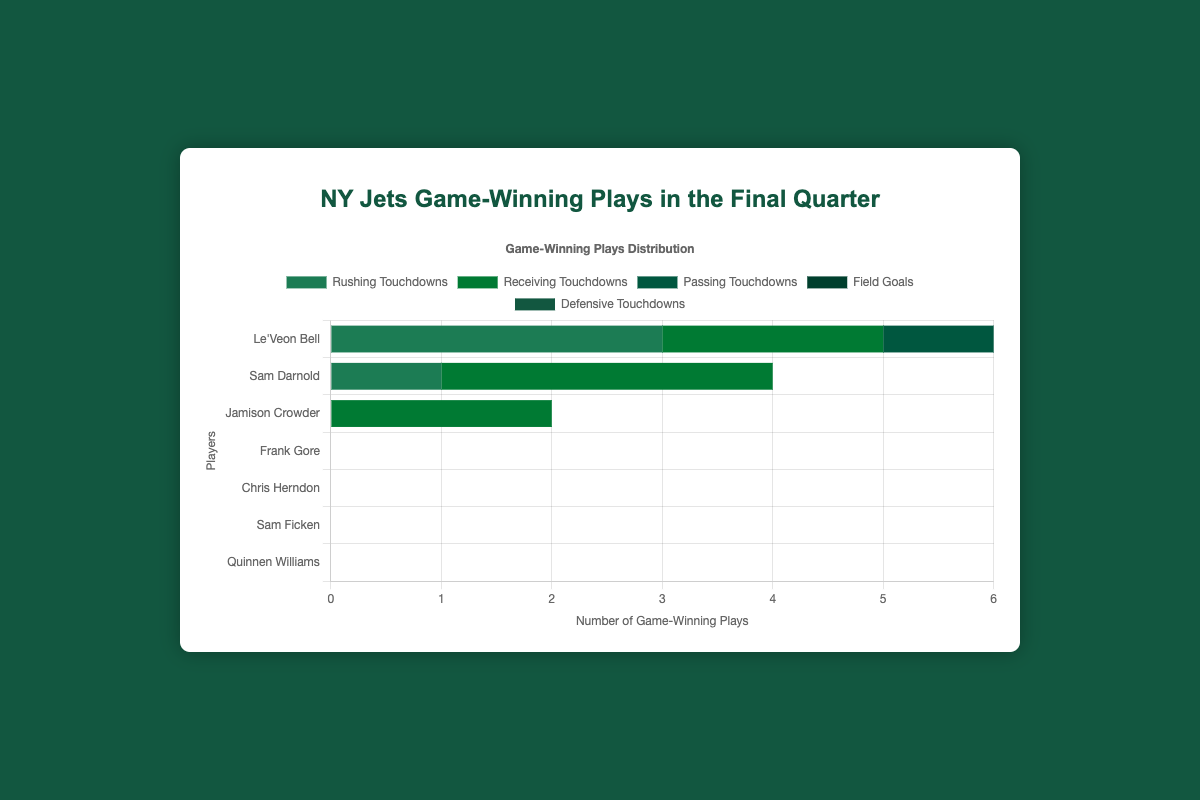Who has the most game-winning plays in the final quarter? By looking at the chart, observe the tallest bar. The "Field Goals" bar for Sam Ficken is the tallest with a height corresponding to 5 game-winning plays. So, Sam Ficken has the most game-winning plays.
Answer: Sam Ficken How many rushing touchdowns does Le'Veon Bell have compared to Frank Gore? Refer to the bars labeled "Rushing Touchdowns" for both players. Le'Veon Bell has 3 game-winning rushing touchdowns, while Frank Gore has 1.
Answer: 3 vs 1 What is the total number of game-winning plays made by Le'Veon Bell? Observe the bars corresponding to Le'Veon Bell and sum their values. Le'Veon Bell has 3 rushing touchdowns and 2 receiving touchdowns, adding up to a total of 5 game-winning plays.
Answer: 5 Which type of play has the highest number of game-winning plays? Look at the chart for the type of play with the highest overall sum of bar heights. "Field Goals" by Sam Ficken has the highest number, which is 5.
Answer: Field Goals How many more game-winning plays does Sam Ficken have than Chris Herndon? Sam Ficken has 5 game-winning plays (Field Goals), while Chris Herndon has 2 (Receiving Touchdowns). The difference is 5 - 2 = 3.
Answer: 3 Which player has both rushing and receiving touchdowns as game-winning plays in the final quarter? Look for players with bars for both "Rushing Touchdowns" and "Receiving Touchdowns." Only Le'Veon Bell fits this criterion.
Answer: Le'Veon Bell How many game-winning plays did the defense contribute? Look for the "Defensive Touchdowns" bar in the chart. Quinnen Williams has the only defensive touchdowns, with 1 game-winning play.
Answer: 1 Which player has the same amount of game-winning receiving touchdowns as Le'Veon Bell? Compare the "Receiving Touchdowns" bar heights for all players. Both Le'Veon Bell and Chris Herndon have 2 game-winning receiving touchdowns each.
Answer: Chris Herndon What’s the combined total of game-winning plays by all players? Sum the values of all the bars: 3 (Le'Veon Bell RT) + 2 (Le'Veon Bell RT) + 4 (Sam Darnold PT) + 3 (Jamison Crowder RT) + 1 (Frank Gore RT) + 2 (Chris Herndon RT) + 5 (Sam Ficken FG) + 1 (Quinnen Williams DT) = 21.
Answer: 21 Who has more game-winning plays from receiving touchdowns, Jamison Crowder or Chris Herndon? Look at the "Receiving Touchdowns" bars for both players. Jamison Crowder has 3, and Chris Herndon has 2.
Answer: Jamison Crowder 